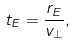Convert formula to latex. <formula><loc_0><loc_0><loc_500><loc_500>t _ { E } = \frac { r _ { E } } { v _ { \perp } } ,</formula> 